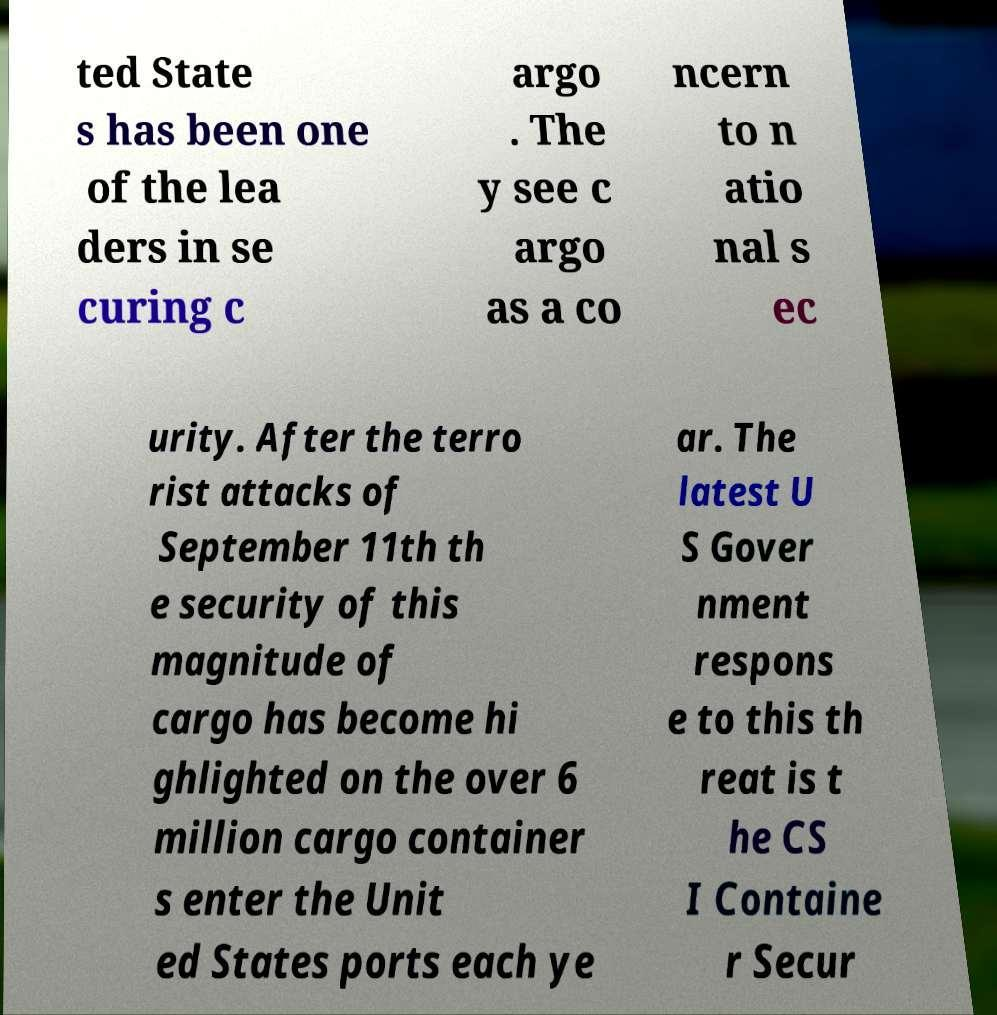Can you read and provide the text displayed in the image?This photo seems to have some interesting text. Can you extract and type it out for me? ted State s has been one of the lea ders in se curing c argo . The y see c argo as a co ncern to n atio nal s ec urity. After the terro rist attacks of September 11th th e security of this magnitude of cargo has become hi ghlighted on the over 6 million cargo container s enter the Unit ed States ports each ye ar. The latest U S Gover nment respons e to this th reat is t he CS I Containe r Secur 